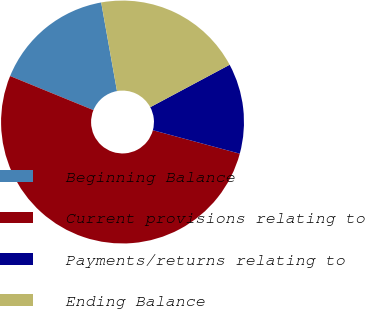<chart> <loc_0><loc_0><loc_500><loc_500><pie_chart><fcel>Beginning Balance<fcel>Current provisions relating to<fcel>Payments/returns relating to<fcel>Ending Balance<nl><fcel>16.01%<fcel>51.98%<fcel>12.01%<fcel>20.0%<nl></chart> 